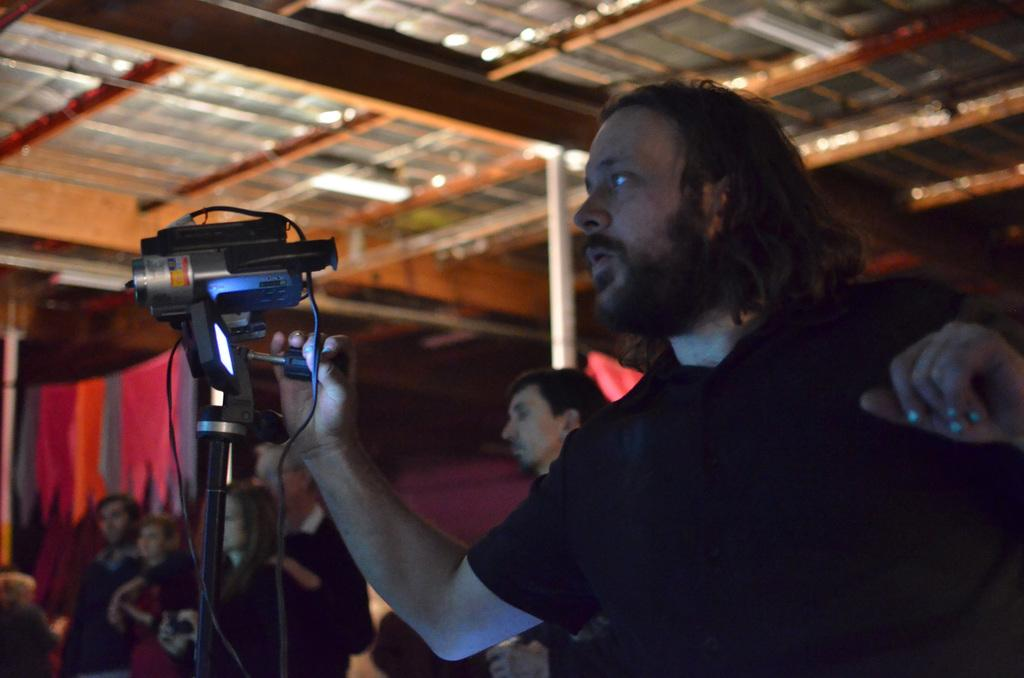Who or what is present in the image? There are people in the image. What object can be seen in the image that is used for capturing images? There is a camera in the image. What type of material is visible in the image? There is cloth in the image. What type of shoe can be seen in the image? There is no shoe present in the image. What is the texture of the cloth in the image? The texture of the cloth cannot be determined from the image alone, as it only provides visual information. 